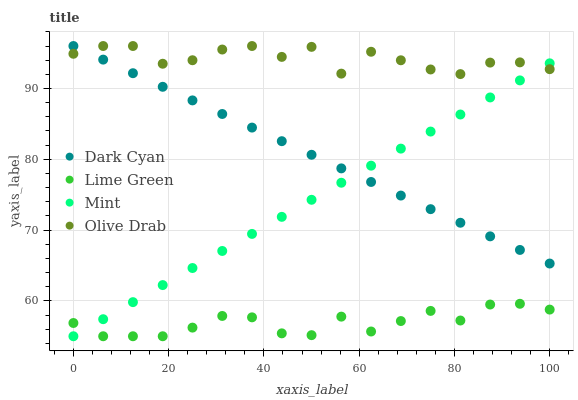Does Lime Green have the minimum area under the curve?
Answer yes or no. Yes. Does Olive Drab have the maximum area under the curve?
Answer yes or no. Yes. Does Mint have the minimum area under the curve?
Answer yes or no. No. Does Mint have the maximum area under the curve?
Answer yes or no. No. Is Dark Cyan the smoothest?
Answer yes or no. Yes. Is Olive Drab the roughest?
Answer yes or no. Yes. Is Lime Green the smoothest?
Answer yes or no. No. Is Lime Green the roughest?
Answer yes or no. No. Does Mint have the lowest value?
Answer yes or no. Yes. Does Olive Drab have the lowest value?
Answer yes or no. No. Does Olive Drab have the highest value?
Answer yes or no. Yes. Does Mint have the highest value?
Answer yes or no. No. Is Lime Green less than Olive Drab?
Answer yes or no. Yes. Is Dark Cyan greater than Lime Green?
Answer yes or no. Yes. Does Olive Drab intersect Dark Cyan?
Answer yes or no. Yes. Is Olive Drab less than Dark Cyan?
Answer yes or no. No. Is Olive Drab greater than Dark Cyan?
Answer yes or no. No. Does Lime Green intersect Olive Drab?
Answer yes or no. No. 